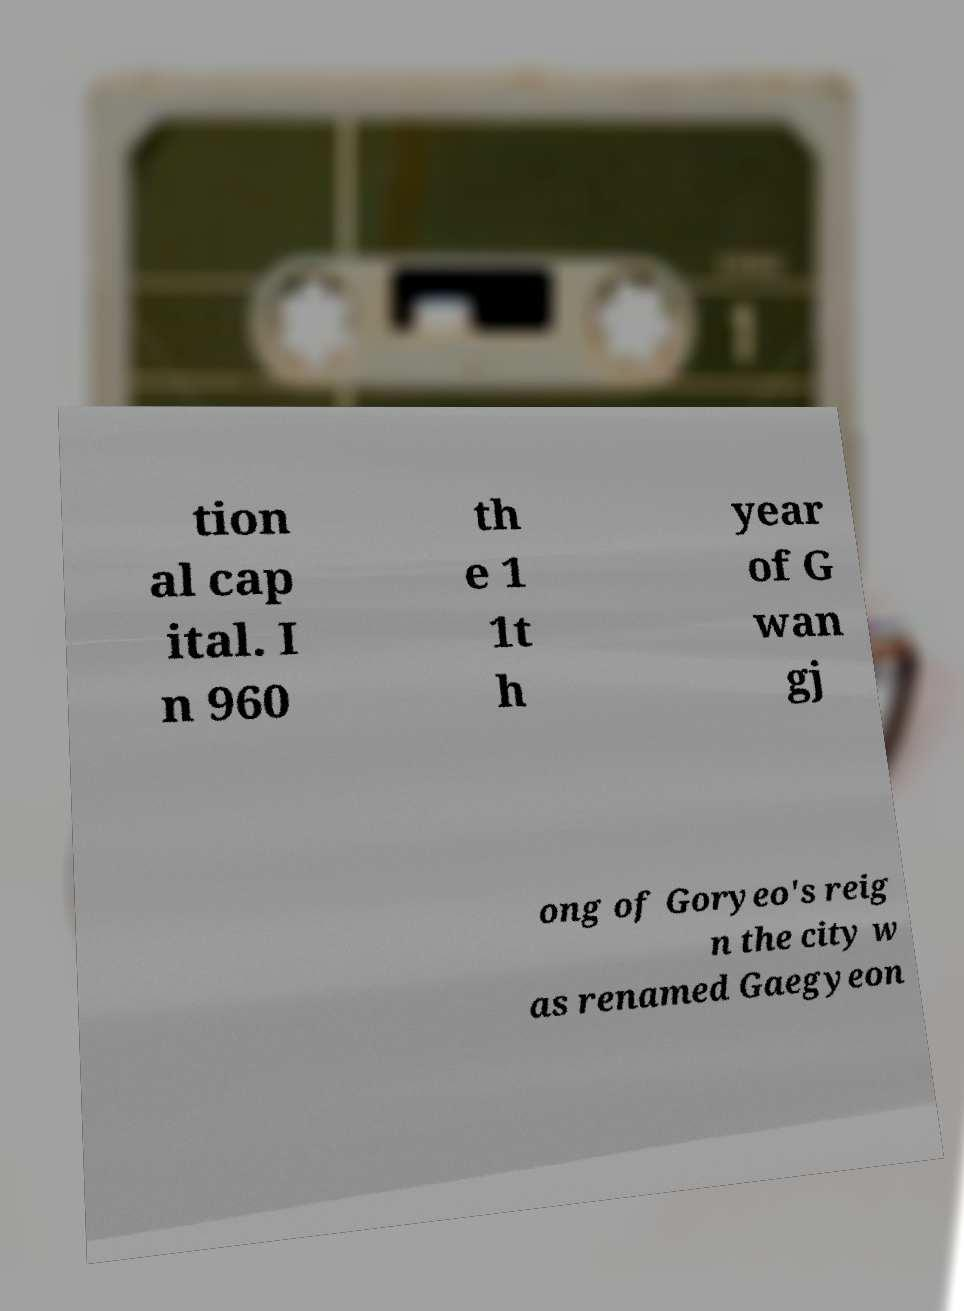There's text embedded in this image that I need extracted. Can you transcribe it verbatim? tion al cap ital. I n 960 th e 1 1t h year of G wan gj ong of Goryeo's reig n the city w as renamed Gaegyeon 